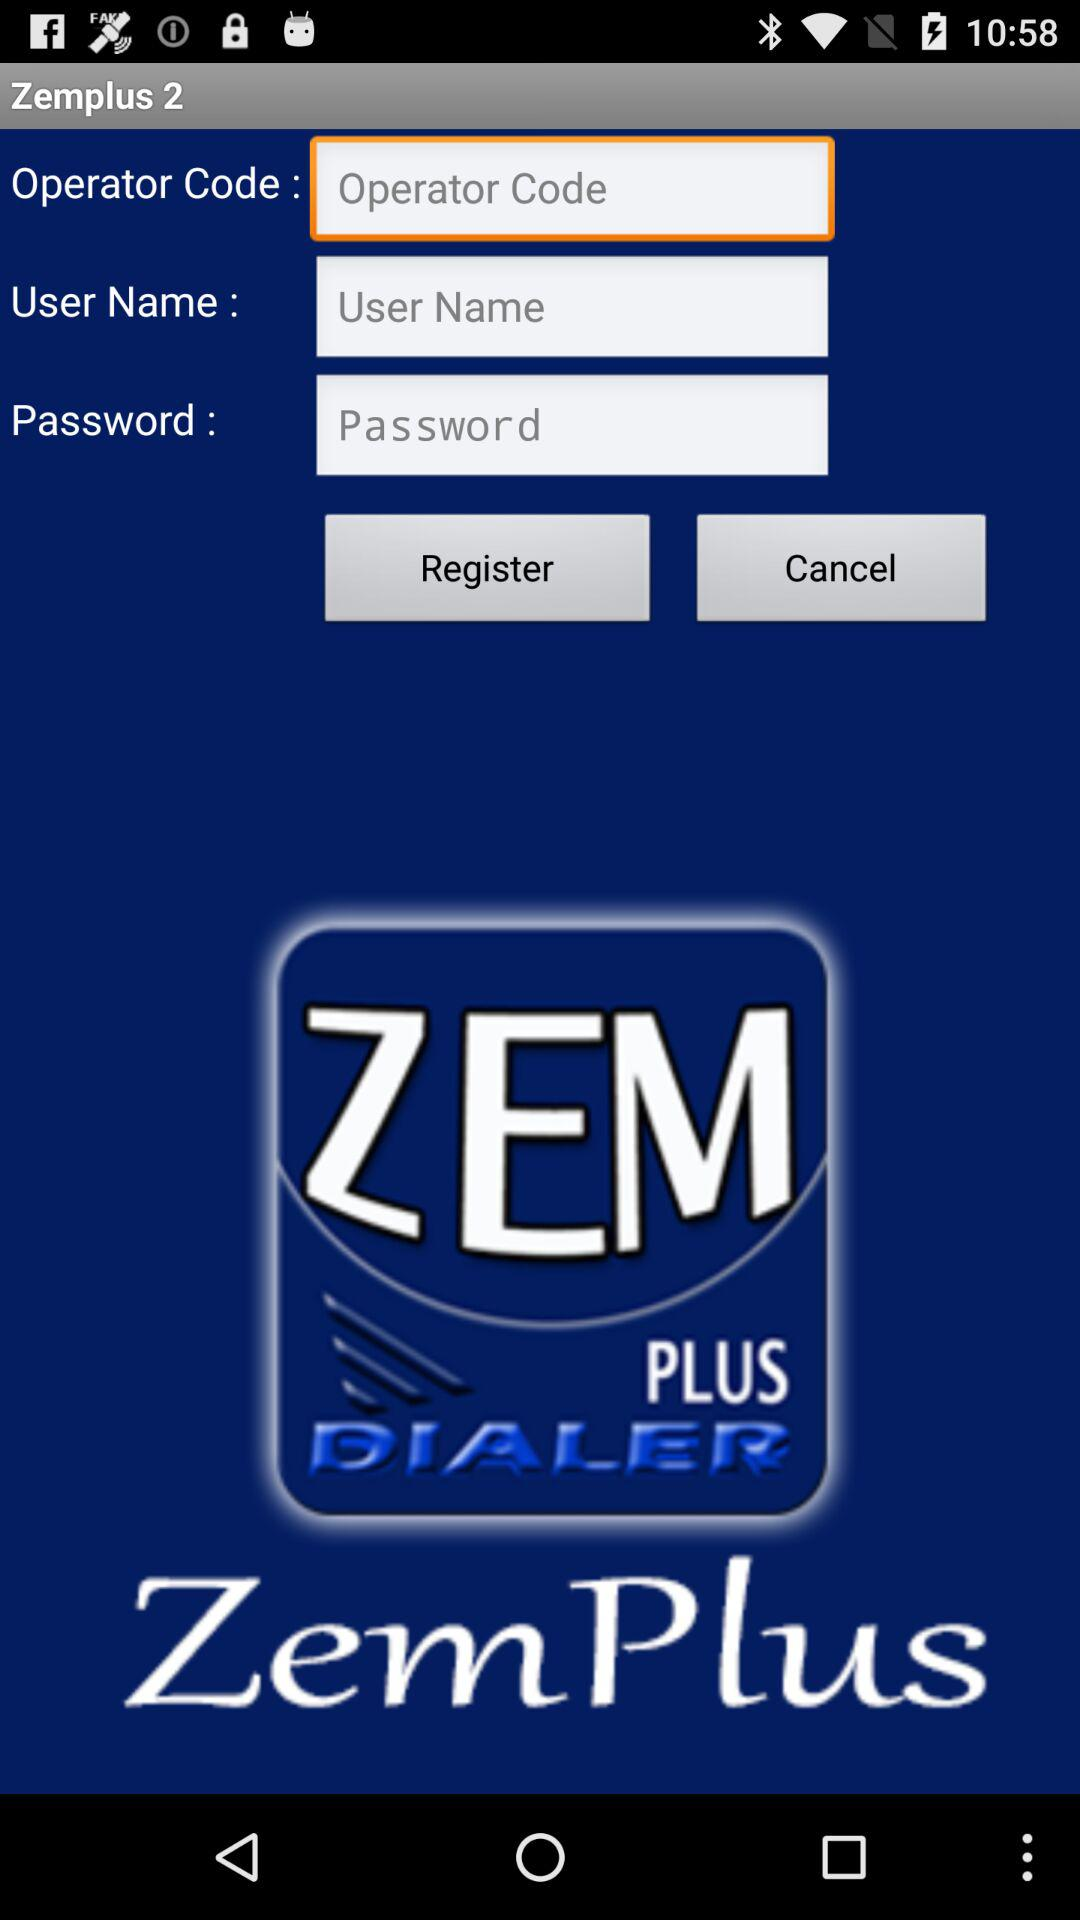What is the application name? The name of the application is Zem Plus Dialer. 